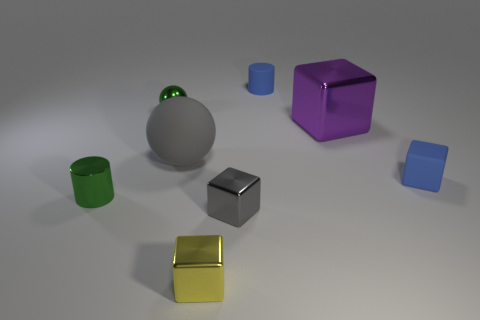Add 1 green matte cubes. How many objects exist? 9 Subtract all large cubes. How many cubes are left? 3 Subtract all purple blocks. How many blocks are left? 3 Subtract 2 cubes. How many cubes are left? 2 Subtract all spheres. How many objects are left? 6 Subtract all large green matte things. Subtract all small shiny cylinders. How many objects are left? 7 Add 2 large shiny things. How many large shiny things are left? 3 Add 3 small shiny cylinders. How many small shiny cylinders exist? 4 Subtract 0 yellow cylinders. How many objects are left? 8 Subtract all green balls. Subtract all yellow cubes. How many balls are left? 1 